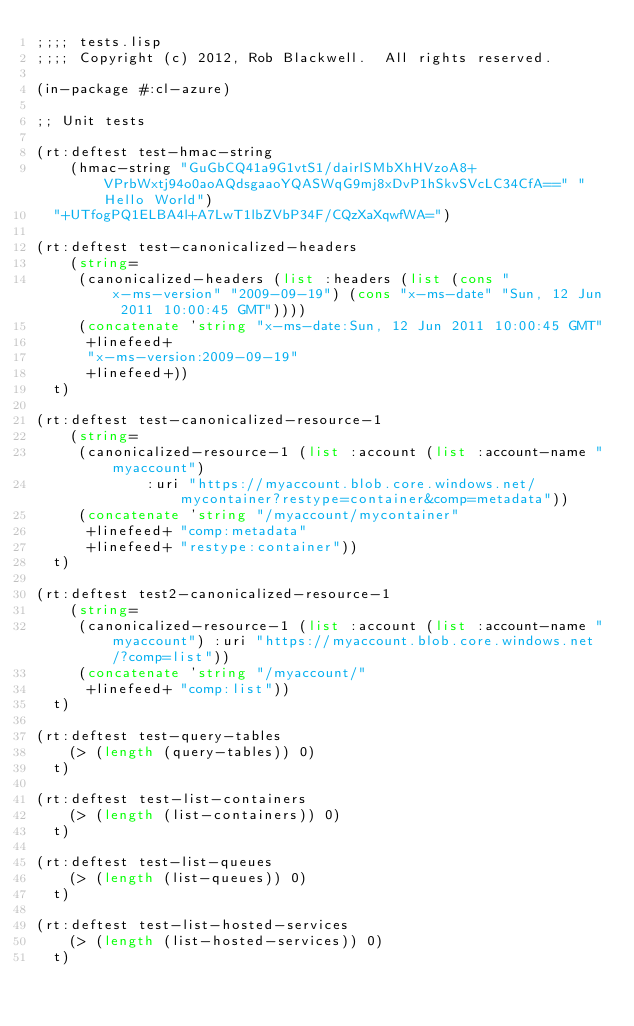<code> <loc_0><loc_0><loc_500><loc_500><_Lisp_>;;;; tests.lisp
;;;; Copyright (c) 2012, Rob Blackwell.  All rights reserved.

(in-package #:cl-azure)

;; Unit tests

(rt:deftest test-hmac-string 
    (hmac-string "GuGbCQ41a9G1vtS1/dairlSMbXhHVzoA8+VPrbWxtj94o0aoAQdsgaaoYQASWqG9mj8xDvP1hSkvSVcLC34CfA==" "Hello World")
  "+UTfogPQ1ELBA4l+A7LwT1lbZVbP34F/CQzXaXqwfWA=")

(rt:deftest test-canonicalized-headers
    (string=
     (canonicalized-headers (list :headers (list (cons "x-ms-version" "2009-09-19") (cons "x-ms-date" "Sun, 12 Jun 2011 10:00:45 GMT"))))
     (concatenate 'string "x-ms-date:Sun, 12 Jun 2011 10:00:45 GMT"
		  +linefeed+
		  "x-ms-version:2009-09-19"
		  +linefeed+))
  t)

(rt:deftest test-canonicalized-resource-1
    (string=
     (canonicalized-resource-1 (list :account (list :account-name "myaccount") 
				     :uri "https://myaccount.blob.core.windows.net/mycontainer?restype=container&comp=metadata"))
     (concatenate 'string "/myaccount/mycontainer"
		  +linefeed+ "comp:metadata"
		  +linefeed+ "restype:container"))
  t)

(rt:deftest test2-canonicalized-resource-1
    (string=
     (canonicalized-resource-1 (list :account (list :account-name "myaccount") :uri "https://myaccount.blob.core.windows.net/?comp=list"))
     (concatenate 'string "/myaccount/"
		  +linefeed+ "comp:list"))
  t)

(rt:deftest test-query-tables
    (> (length (query-tables)) 0)
  t)

(rt:deftest test-list-containers
    (> (length (list-containers)) 0)
  t)

(rt:deftest test-list-queues
    (> (length (list-queues)) 0)
  t)

(rt:deftest test-list-hosted-services
    (> (length (list-hosted-services)) 0)
  t)

</code> 